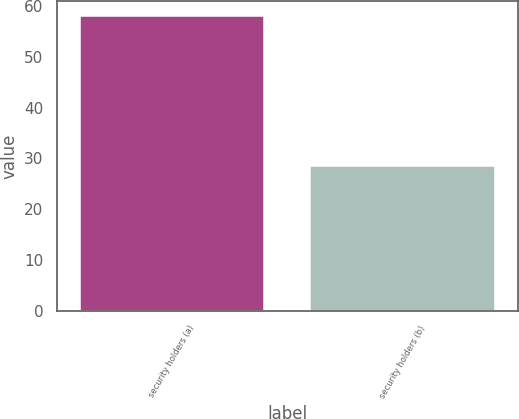Convert chart. <chart><loc_0><loc_0><loc_500><loc_500><bar_chart><fcel>security holders (a)<fcel>security holders (b)<nl><fcel>58.02<fcel>28.53<nl></chart> 